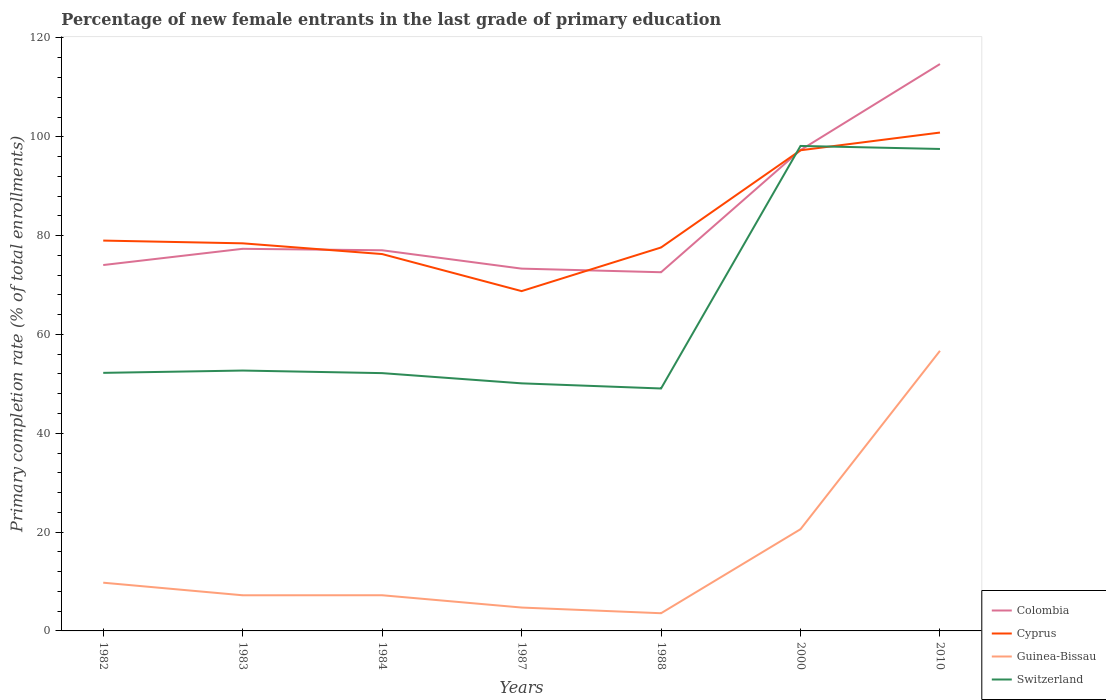Across all years, what is the maximum percentage of new female entrants in Guinea-Bissau?
Your response must be concise. 3.58. What is the total percentage of new female entrants in Cyprus in the graph?
Your response must be concise. -8.83. What is the difference between the highest and the second highest percentage of new female entrants in Cyprus?
Your answer should be compact. 32.09. What is the difference between the highest and the lowest percentage of new female entrants in Cyprus?
Provide a short and direct response. 2. Is the percentage of new female entrants in Colombia strictly greater than the percentage of new female entrants in Switzerland over the years?
Give a very brief answer. No. How many lines are there?
Give a very brief answer. 4. How many years are there in the graph?
Offer a terse response. 7. What is the difference between two consecutive major ticks on the Y-axis?
Your answer should be compact. 20. Does the graph contain any zero values?
Make the answer very short. No. What is the title of the graph?
Provide a succinct answer. Percentage of new female entrants in the last grade of primary education. What is the label or title of the X-axis?
Offer a terse response. Years. What is the label or title of the Y-axis?
Keep it short and to the point. Primary completion rate (% of total enrollments). What is the Primary completion rate (% of total enrollments) of Colombia in 1982?
Keep it short and to the point. 74.05. What is the Primary completion rate (% of total enrollments) of Cyprus in 1982?
Your answer should be compact. 79. What is the Primary completion rate (% of total enrollments) in Guinea-Bissau in 1982?
Give a very brief answer. 9.76. What is the Primary completion rate (% of total enrollments) in Switzerland in 1982?
Provide a succinct answer. 52.23. What is the Primary completion rate (% of total enrollments) of Colombia in 1983?
Give a very brief answer. 77.33. What is the Primary completion rate (% of total enrollments) in Cyprus in 1983?
Provide a short and direct response. 78.44. What is the Primary completion rate (% of total enrollments) in Guinea-Bissau in 1983?
Give a very brief answer. 7.21. What is the Primary completion rate (% of total enrollments) in Switzerland in 1983?
Provide a succinct answer. 52.7. What is the Primary completion rate (% of total enrollments) of Colombia in 1984?
Offer a terse response. 77.04. What is the Primary completion rate (% of total enrollments) of Cyprus in 1984?
Provide a short and direct response. 76.27. What is the Primary completion rate (% of total enrollments) of Guinea-Bissau in 1984?
Provide a short and direct response. 7.22. What is the Primary completion rate (% of total enrollments) in Switzerland in 1984?
Provide a short and direct response. 52.17. What is the Primary completion rate (% of total enrollments) in Colombia in 1987?
Your response must be concise. 73.32. What is the Primary completion rate (% of total enrollments) in Cyprus in 1987?
Your response must be concise. 68.77. What is the Primary completion rate (% of total enrollments) in Guinea-Bissau in 1987?
Provide a succinct answer. 4.73. What is the Primary completion rate (% of total enrollments) of Switzerland in 1987?
Your answer should be very brief. 50.11. What is the Primary completion rate (% of total enrollments) of Colombia in 1988?
Offer a terse response. 72.59. What is the Primary completion rate (% of total enrollments) in Cyprus in 1988?
Ensure brevity in your answer.  77.6. What is the Primary completion rate (% of total enrollments) of Guinea-Bissau in 1988?
Ensure brevity in your answer.  3.58. What is the Primary completion rate (% of total enrollments) in Switzerland in 1988?
Offer a very short reply. 49.06. What is the Primary completion rate (% of total enrollments) in Colombia in 2000?
Give a very brief answer. 97.31. What is the Primary completion rate (% of total enrollments) in Cyprus in 2000?
Provide a succinct answer. 97.27. What is the Primary completion rate (% of total enrollments) in Guinea-Bissau in 2000?
Give a very brief answer. 20.58. What is the Primary completion rate (% of total enrollments) in Switzerland in 2000?
Offer a very short reply. 98.15. What is the Primary completion rate (% of total enrollments) in Colombia in 2010?
Your response must be concise. 114.73. What is the Primary completion rate (% of total enrollments) in Cyprus in 2010?
Your answer should be very brief. 100.86. What is the Primary completion rate (% of total enrollments) in Guinea-Bissau in 2010?
Make the answer very short. 56.69. What is the Primary completion rate (% of total enrollments) in Switzerland in 2010?
Provide a short and direct response. 97.54. Across all years, what is the maximum Primary completion rate (% of total enrollments) of Colombia?
Your response must be concise. 114.73. Across all years, what is the maximum Primary completion rate (% of total enrollments) of Cyprus?
Keep it short and to the point. 100.86. Across all years, what is the maximum Primary completion rate (% of total enrollments) in Guinea-Bissau?
Make the answer very short. 56.69. Across all years, what is the maximum Primary completion rate (% of total enrollments) of Switzerland?
Provide a short and direct response. 98.15. Across all years, what is the minimum Primary completion rate (% of total enrollments) of Colombia?
Provide a succinct answer. 72.59. Across all years, what is the minimum Primary completion rate (% of total enrollments) in Cyprus?
Provide a succinct answer. 68.77. Across all years, what is the minimum Primary completion rate (% of total enrollments) in Guinea-Bissau?
Provide a succinct answer. 3.58. Across all years, what is the minimum Primary completion rate (% of total enrollments) in Switzerland?
Offer a very short reply. 49.06. What is the total Primary completion rate (% of total enrollments) in Colombia in the graph?
Give a very brief answer. 586.37. What is the total Primary completion rate (% of total enrollments) of Cyprus in the graph?
Provide a short and direct response. 578.21. What is the total Primary completion rate (% of total enrollments) in Guinea-Bissau in the graph?
Offer a very short reply. 109.78. What is the total Primary completion rate (% of total enrollments) in Switzerland in the graph?
Make the answer very short. 451.96. What is the difference between the Primary completion rate (% of total enrollments) in Colombia in 1982 and that in 1983?
Provide a succinct answer. -3.28. What is the difference between the Primary completion rate (% of total enrollments) of Cyprus in 1982 and that in 1983?
Keep it short and to the point. 0.56. What is the difference between the Primary completion rate (% of total enrollments) of Guinea-Bissau in 1982 and that in 1983?
Offer a very short reply. 2.55. What is the difference between the Primary completion rate (% of total enrollments) in Switzerland in 1982 and that in 1983?
Give a very brief answer. -0.47. What is the difference between the Primary completion rate (% of total enrollments) in Colombia in 1982 and that in 1984?
Provide a succinct answer. -2.99. What is the difference between the Primary completion rate (% of total enrollments) in Cyprus in 1982 and that in 1984?
Your response must be concise. 2.73. What is the difference between the Primary completion rate (% of total enrollments) in Guinea-Bissau in 1982 and that in 1984?
Offer a very short reply. 2.54. What is the difference between the Primary completion rate (% of total enrollments) of Switzerland in 1982 and that in 1984?
Provide a short and direct response. 0.06. What is the difference between the Primary completion rate (% of total enrollments) of Colombia in 1982 and that in 1987?
Keep it short and to the point. 0.73. What is the difference between the Primary completion rate (% of total enrollments) of Cyprus in 1982 and that in 1987?
Your response must be concise. 10.23. What is the difference between the Primary completion rate (% of total enrollments) of Guinea-Bissau in 1982 and that in 1987?
Provide a succinct answer. 5.03. What is the difference between the Primary completion rate (% of total enrollments) in Switzerland in 1982 and that in 1987?
Your answer should be compact. 2.12. What is the difference between the Primary completion rate (% of total enrollments) of Colombia in 1982 and that in 1988?
Provide a succinct answer. 1.46. What is the difference between the Primary completion rate (% of total enrollments) in Cyprus in 1982 and that in 1988?
Offer a very short reply. 1.4. What is the difference between the Primary completion rate (% of total enrollments) of Guinea-Bissau in 1982 and that in 1988?
Give a very brief answer. 6.18. What is the difference between the Primary completion rate (% of total enrollments) of Switzerland in 1982 and that in 1988?
Your answer should be very brief. 3.16. What is the difference between the Primary completion rate (% of total enrollments) in Colombia in 1982 and that in 2000?
Keep it short and to the point. -23.26. What is the difference between the Primary completion rate (% of total enrollments) in Cyprus in 1982 and that in 2000?
Your response must be concise. -18.28. What is the difference between the Primary completion rate (% of total enrollments) in Guinea-Bissau in 1982 and that in 2000?
Keep it short and to the point. -10.82. What is the difference between the Primary completion rate (% of total enrollments) in Switzerland in 1982 and that in 2000?
Offer a very short reply. -45.92. What is the difference between the Primary completion rate (% of total enrollments) in Colombia in 1982 and that in 2010?
Your response must be concise. -40.68. What is the difference between the Primary completion rate (% of total enrollments) in Cyprus in 1982 and that in 2010?
Your response must be concise. -21.86. What is the difference between the Primary completion rate (% of total enrollments) in Guinea-Bissau in 1982 and that in 2010?
Provide a short and direct response. -46.93. What is the difference between the Primary completion rate (% of total enrollments) of Switzerland in 1982 and that in 2010?
Ensure brevity in your answer.  -45.31. What is the difference between the Primary completion rate (% of total enrollments) of Colombia in 1983 and that in 1984?
Provide a short and direct response. 0.3. What is the difference between the Primary completion rate (% of total enrollments) in Cyprus in 1983 and that in 1984?
Ensure brevity in your answer.  2.17. What is the difference between the Primary completion rate (% of total enrollments) in Guinea-Bissau in 1983 and that in 1984?
Offer a very short reply. -0.01. What is the difference between the Primary completion rate (% of total enrollments) in Switzerland in 1983 and that in 1984?
Make the answer very short. 0.52. What is the difference between the Primary completion rate (% of total enrollments) in Colombia in 1983 and that in 1987?
Offer a very short reply. 4.01. What is the difference between the Primary completion rate (% of total enrollments) in Cyprus in 1983 and that in 1987?
Provide a short and direct response. 9.67. What is the difference between the Primary completion rate (% of total enrollments) in Guinea-Bissau in 1983 and that in 1987?
Make the answer very short. 2.48. What is the difference between the Primary completion rate (% of total enrollments) of Switzerland in 1983 and that in 1987?
Keep it short and to the point. 2.59. What is the difference between the Primary completion rate (% of total enrollments) of Colombia in 1983 and that in 1988?
Your answer should be very brief. 4.74. What is the difference between the Primary completion rate (% of total enrollments) of Cyprus in 1983 and that in 1988?
Offer a terse response. 0.84. What is the difference between the Primary completion rate (% of total enrollments) of Guinea-Bissau in 1983 and that in 1988?
Ensure brevity in your answer.  3.63. What is the difference between the Primary completion rate (% of total enrollments) of Switzerland in 1983 and that in 1988?
Make the answer very short. 3.63. What is the difference between the Primary completion rate (% of total enrollments) in Colombia in 1983 and that in 2000?
Offer a terse response. -19.98. What is the difference between the Primary completion rate (% of total enrollments) in Cyprus in 1983 and that in 2000?
Provide a short and direct response. -18.83. What is the difference between the Primary completion rate (% of total enrollments) of Guinea-Bissau in 1983 and that in 2000?
Provide a short and direct response. -13.37. What is the difference between the Primary completion rate (% of total enrollments) in Switzerland in 1983 and that in 2000?
Make the answer very short. -45.46. What is the difference between the Primary completion rate (% of total enrollments) in Colombia in 1983 and that in 2010?
Provide a short and direct response. -37.39. What is the difference between the Primary completion rate (% of total enrollments) of Cyprus in 1983 and that in 2010?
Offer a terse response. -22.42. What is the difference between the Primary completion rate (% of total enrollments) in Guinea-Bissau in 1983 and that in 2010?
Ensure brevity in your answer.  -49.48. What is the difference between the Primary completion rate (% of total enrollments) of Switzerland in 1983 and that in 2010?
Provide a succinct answer. -44.84. What is the difference between the Primary completion rate (% of total enrollments) of Colombia in 1984 and that in 1987?
Provide a short and direct response. 3.72. What is the difference between the Primary completion rate (% of total enrollments) in Cyprus in 1984 and that in 1987?
Provide a short and direct response. 7.5. What is the difference between the Primary completion rate (% of total enrollments) in Guinea-Bissau in 1984 and that in 1987?
Offer a terse response. 2.49. What is the difference between the Primary completion rate (% of total enrollments) in Switzerland in 1984 and that in 1987?
Ensure brevity in your answer.  2.07. What is the difference between the Primary completion rate (% of total enrollments) in Colombia in 1984 and that in 1988?
Keep it short and to the point. 4.45. What is the difference between the Primary completion rate (% of total enrollments) of Cyprus in 1984 and that in 1988?
Offer a very short reply. -1.33. What is the difference between the Primary completion rate (% of total enrollments) of Guinea-Bissau in 1984 and that in 1988?
Your answer should be very brief. 3.64. What is the difference between the Primary completion rate (% of total enrollments) in Switzerland in 1984 and that in 1988?
Keep it short and to the point. 3.11. What is the difference between the Primary completion rate (% of total enrollments) of Colombia in 1984 and that in 2000?
Your answer should be very brief. -20.27. What is the difference between the Primary completion rate (% of total enrollments) in Cyprus in 1984 and that in 2000?
Provide a short and direct response. -21. What is the difference between the Primary completion rate (% of total enrollments) in Guinea-Bissau in 1984 and that in 2000?
Your answer should be compact. -13.37. What is the difference between the Primary completion rate (% of total enrollments) in Switzerland in 1984 and that in 2000?
Offer a very short reply. -45.98. What is the difference between the Primary completion rate (% of total enrollments) in Colombia in 1984 and that in 2010?
Give a very brief answer. -37.69. What is the difference between the Primary completion rate (% of total enrollments) of Cyprus in 1984 and that in 2010?
Your answer should be compact. -24.59. What is the difference between the Primary completion rate (% of total enrollments) of Guinea-Bissau in 1984 and that in 2010?
Your response must be concise. -49.47. What is the difference between the Primary completion rate (% of total enrollments) in Switzerland in 1984 and that in 2010?
Keep it short and to the point. -45.37. What is the difference between the Primary completion rate (% of total enrollments) in Colombia in 1987 and that in 1988?
Keep it short and to the point. 0.73. What is the difference between the Primary completion rate (% of total enrollments) in Cyprus in 1987 and that in 1988?
Provide a short and direct response. -8.83. What is the difference between the Primary completion rate (% of total enrollments) of Guinea-Bissau in 1987 and that in 1988?
Make the answer very short. 1.15. What is the difference between the Primary completion rate (% of total enrollments) in Switzerland in 1987 and that in 1988?
Keep it short and to the point. 1.04. What is the difference between the Primary completion rate (% of total enrollments) of Colombia in 1987 and that in 2000?
Provide a succinct answer. -23.99. What is the difference between the Primary completion rate (% of total enrollments) of Cyprus in 1987 and that in 2000?
Ensure brevity in your answer.  -28.5. What is the difference between the Primary completion rate (% of total enrollments) in Guinea-Bissau in 1987 and that in 2000?
Your answer should be compact. -15.85. What is the difference between the Primary completion rate (% of total enrollments) in Switzerland in 1987 and that in 2000?
Offer a terse response. -48.05. What is the difference between the Primary completion rate (% of total enrollments) of Colombia in 1987 and that in 2010?
Ensure brevity in your answer.  -41.41. What is the difference between the Primary completion rate (% of total enrollments) in Cyprus in 1987 and that in 2010?
Make the answer very short. -32.09. What is the difference between the Primary completion rate (% of total enrollments) of Guinea-Bissau in 1987 and that in 2010?
Give a very brief answer. -51.96. What is the difference between the Primary completion rate (% of total enrollments) of Switzerland in 1987 and that in 2010?
Ensure brevity in your answer.  -47.43. What is the difference between the Primary completion rate (% of total enrollments) of Colombia in 1988 and that in 2000?
Provide a short and direct response. -24.72. What is the difference between the Primary completion rate (% of total enrollments) of Cyprus in 1988 and that in 2000?
Provide a short and direct response. -19.67. What is the difference between the Primary completion rate (% of total enrollments) of Guinea-Bissau in 1988 and that in 2000?
Your answer should be compact. -17. What is the difference between the Primary completion rate (% of total enrollments) in Switzerland in 1988 and that in 2000?
Keep it short and to the point. -49.09. What is the difference between the Primary completion rate (% of total enrollments) of Colombia in 1988 and that in 2010?
Your answer should be very brief. -42.14. What is the difference between the Primary completion rate (% of total enrollments) of Cyprus in 1988 and that in 2010?
Your response must be concise. -23.26. What is the difference between the Primary completion rate (% of total enrollments) of Guinea-Bissau in 1988 and that in 2010?
Provide a succinct answer. -53.11. What is the difference between the Primary completion rate (% of total enrollments) of Switzerland in 1988 and that in 2010?
Offer a very short reply. -48.47. What is the difference between the Primary completion rate (% of total enrollments) in Colombia in 2000 and that in 2010?
Your response must be concise. -17.41. What is the difference between the Primary completion rate (% of total enrollments) in Cyprus in 2000 and that in 2010?
Ensure brevity in your answer.  -3.59. What is the difference between the Primary completion rate (% of total enrollments) of Guinea-Bissau in 2000 and that in 2010?
Provide a short and direct response. -36.1. What is the difference between the Primary completion rate (% of total enrollments) of Switzerland in 2000 and that in 2010?
Your answer should be compact. 0.61. What is the difference between the Primary completion rate (% of total enrollments) of Colombia in 1982 and the Primary completion rate (% of total enrollments) of Cyprus in 1983?
Make the answer very short. -4.39. What is the difference between the Primary completion rate (% of total enrollments) of Colombia in 1982 and the Primary completion rate (% of total enrollments) of Guinea-Bissau in 1983?
Make the answer very short. 66.84. What is the difference between the Primary completion rate (% of total enrollments) in Colombia in 1982 and the Primary completion rate (% of total enrollments) in Switzerland in 1983?
Give a very brief answer. 21.35. What is the difference between the Primary completion rate (% of total enrollments) in Cyprus in 1982 and the Primary completion rate (% of total enrollments) in Guinea-Bissau in 1983?
Provide a succinct answer. 71.78. What is the difference between the Primary completion rate (% of total enrollments) in Cyprus in 1982 and the Primary completion rate (% of total enrollments) in Switzerland in 1983?
Make the answer very short. 26.3. What is the difference between the Primary completion rate (% of total enrollments) in Guinea-Bissau in 1982 and the Primary completion rate (% of total enrollments) in Switzerland in 1983?
Your response must be concise. -42.94. What is the difference between the Primary completion rate (% of total enrollments) of Colombia in 1982 and the Primary completion rate (% of total enrollments) of Cyprus in 1984?
Ensure brevity in your answer.  -2.22. What is the difference between the Primary completion rate (% of total enrollments) of Colombia in 1982 and the Primary completion rate (% of total enrollments) of Guinea-Bissau in 1984?
Keep it short and to the point. 66.83. What is the difference between the Primary completion rate (% of total enrollments) in Colombia in 1982 and the Primary completion rate (% of total enrollments) in Switzerland in 1984?
Keep it short and to the point. 21.88. What is the difference between the Primary completion rate (% of total enrollments) of Cyprus in 1982 and the Primary completion rate (% of total enrollments) of Guinea-Bissau in 1984?
Offer a terse response. 71.78. What is the difference between the Primary completion rate (% of total enrollments) in Cyprus in 1982 and the Primary completion rate (% of total enrollments) in Switzerland in 1984?
Make the answer very short. 26.82. What is the difference between the Primary completion rate (% of total enrollments) in Guinea-Bissau in 1982 and the Primary completion rate (% of total enrollments) in Switzerland in 1984?
Ensure brevity in your answer.  -42.41. What is the difference between the Primary completion rate (% of total enrollments) in Colombia in 1982 and the Primary completion rate (% of total enrollments) in Cyprus in 1987?
Offer a terse response. 5.28. What is the difference between the Primary completion rate (% of total enrollments) of Colombia in 1982 and the Primary completion rate (% of total enrollments) of Guinea-Bissau in 1987?
Provide a succinct answer. 69.32. What is the difference between the Primary completion rate (% of total enrollments) of Colombia in 1982 and the Primary completion rate (% of total enrollments) of Switzerland in 1987?
Your answer should be compact. 23.94. What is the difference between the Primary completion rate (% of total enrollments) in Cyprus in 1982 and the Primary completion rate (% of total enrollments) in Guinea-Bissau in 1987?
Your answer should be compact. 74.27. What is the difference between the Primary completion rate (% of total enrollments) of Cyprus in 1982 and the Primary completion rate (% of total enrollments) of Switzerland in 1987?
Your answer should be compact. 28.89. What is the difference between the Primary completion rate (% of total enrollments) in Guinea-Bissau in 1982 and the Primary completion rate (% of total enrollments) in Switzerland in 1987?
Ensure brevity in your answer.  -40.35. What is the difference between the Primary completion rate (% of total enrollments) of Colombia in 1982 and the Primary completion rate (% of total enrollments) of Cyprus in 1988?
Ensure brevity in your answer.  -3.55. What is the difference between the Primary completion rate (% of total enrollments) in Colombia in 1982 and the Primary completion rate (% of total enrollments) in Guinea-Bissau in 1988?
Ensure brevity in your answer.  70.47. What is the difference between the Primary completion rate (% of total enrollments) in Colombia in 1982 and the Primary completion rate (% of total enrollments) in Switzerland in 1988?
Make the answer very short. 24.98. What is the difference between the Primary completion rate (% of total enrollments) in Cyprus in 1982 and the Primary completion rate (% of total enrollments) in Guinea-Bissau in 1988?
Give a very brief answer. 75.42. What is the difference between the Primary completion rate (% of total enrollments) of Cyprus in 1982 and the Primary completion rate (% of total enrollments) of Switzerland in 1988?
Keep it short and to the point. 29.93. What is the difference between the Primary completion rate (% of total enrollments) in Guinea-Bissau in 1982 and the Primary completion rate (% of total enrollments) in Switzerland in 1988?
Provide a succinct answer. -39.3. What is the difference between the Primary completion rate (% of total enrollments) of Colombia in 1982 and the Primary completion rate (% of total enrollments) of Cyprus in 2000?
Provide a short and direct response. -23.22. What is the difference between the Primary completion rate (% of total enrollments) in Colombia in 1982 and the Primary completion rate (% of total enrollments) in Guinea-Bissau in 2000?
Give a very brief answer. 53.46. What is the difference between the Primary completion rate (% of total enrollments) in Colombia in 1982 and the Primary completion rate (% of total enrollments) in Switzerland in 2000?
Offer a terse response. -24.1. What is the difference between the Primary completion rate (% of total enrollments) in Cyprus in 1982 and the Primary completion rate (% of total enrollments) in Guinea-Bissau in 2000?
Your answer should be compact. 58.41. What is the difference between the Primary completion rate (% of total enrollments) of Cyprus in 1982 and the Primary completion rate (% of total enrollments) of Switzerland in 2000?
Ensure brevity in your answer.  -19.15. What is the difference between the Primary completion rate (% of total enrollments) in Guinea-Bissau in 1982 and the Primary completion rate (% of total enrollments) in Switzerland in 2000?
Provide a short and direct response. -88.39. What is the difference between the Primary completion rate (% of total enrollments) in Colombia in 1982 and the Primary completion rate (% of total enrollments) in Cyprus in 2010?
Provide a short and direct response. -26.81. What is the difference between the Primary completion rate (% of total enrollments) of Colombia in 1982 and the Primary completion rate (% of total enrollments) of Guinea-Bissau in 2010?
Offer a terse response. 17.36. What is the difference between the Primary completion rate (% of total enrollments) in Colombia in 1982 and the Primary completion rate (% of total enrollments) in Switzerland in 2010?
Provide a succinct answer. -23.49. What is the difference between the Primary completion rate (% of total enrollments) of Cyprus in 1982 and the Primary completion rate (% of total enrollments) of Guinea-Bissau in 2010?
Offer a very short reply. 22.31. What is the difference between the Primary completion rate (% of total enrollments) in Cyprus in 1982 and the Primary completion rate (% of total enrollments) in Switzerland in 2010?
Offer a very short reply. -18.54. What is the difference between the Primary completion rate (% of total enrollments) of Guinea-Bissau in 1982 and the Primary completion rate (% of total enrollments) of Switzerland in 2010?
Provide a succinct answer. -87.78. What is the difference between the Primary completion rate (% of total enrollments) of Colombia in 1983 and the Primary completion rate (% of total enrollments) of Cyprus in 1984?
Offer a terse response. 1.06. What is the difference between the Primary completion rate (% of total enrollments) of Colombia in 1983 and the Primary completion rate (% of total enrollments) of Guinea-Bissau in 1984?
Keep it short and to the point. 70.11. What is the difference between the Primary completion rate (% of total enrollments) in Colombia in 1983 and the Primary completion rate (% of total enrollments) in Switzerland in 1984?
Make the answer very short. 25.16. What is the difference between the Primary completion rate (% of total enrollments) in Cyprus in 1983 and the Primary completion rate (% of total enrollments) in Guinea-Bissau in 1984?
Ensure brevity in your answer.  71.22. What is the difference between the Primary completion rate (% of total enrollments) of Cyprus in 1983 and the Primary completion rate (% of total enrollments) of Switzerland in 1984?
Make the answer very short. 26.27. What is the difference between the Primary completion rate (% of total enrollments) of Guinea-Bissau in 1983 and the Primary completion rate (% of total enrollments) of Switzerland in 1984?
Your answer should be compact. -44.96. What is the difference between the Primary completion rate (% of total enrollments) in Colombia in 1983 and the Primary completion rate (% of total enrollments) in Cyprus in 1987?
Provide a short and direct response. 8.56. What is the difference between the Primary completion rate (% of total enrollments) of Colombia in 1983 and the Primary completion rate (% of total enrollments) of Guinea-Bissau in 1987?
Your answer should be compact. 72.6. What is the difference between the Primary completion rate (% of total enrollments) of Colombia in 1983 and the Primary completion rate (% of total enrollments) of Switzerland in 1987?
Provide a short and direct response. 27.23. What is the difference between the Primary completion rate (% of total enrollments) of Cyprus in 1983 and the Primary completion rate (% of total enrollments) of Guinea-Bissau in 1987?
Your response must be concise. 73.71. What is the difference between the Primary completion rate (% of total enrollments) of Cyprus in 1983 and the Primary completion rate (% of total enrollments) of Switzerland in 1987?
Offer a very short reply. 28.34. What is the difference between the Primary completion rate (% of total enrollments) in Guinea-Bissau in 1983 and the Primary completion rate (% of total enrollments) in Switzerland in 1987?
Offer a very short reply. -42.89. What is the difference between the Primary completion rate (% of total enrollments) in Colombia in 1983 and the Primary completion rate (% of total enrollments) in Cyprus in 1988?
Provide a succinct answer. -0.27. What is the difference between the Primary completion rate (% of total enrollments) in Colombia in 1983 and the Primary completion rate (% of total enrollments) in Guinea-Bissau in 1988?
Provide a succinct answer. 73.75. What is the difference between the Primary completion rate (% of total enrollments) in Colombia in 1983 and the Primary completion rate (% of total enrollments) in Switzerland in 1988?
Your answer should be compact. 28.27. What is the difference between the Primary completion rate (% of total enrollments) of Cyprus in 1983 and the Primary completion rate (% of total enrollments) of Guinea-Bissau in 1988?
Your answer should be very brief. 74.86. What is the difference between the Primary completion rate (% of total enrollments) in Cyprus in 1983 and the Primary completion rate (% of total enrollments) in Switzerland in 1988?
Ensure brevity in your answer.  29.38. What is the difference between the Primary completion rate (% of total enrollments) of Guinea-Bissau in 1983 and the Primary completion rate (% of total enrollments) of Switzerland in 1988?
Provide a short and direct response. -41.85. What is the difference between the Primary completion rate (% of total enrollments) in Colombia in 1983 and the Primary completion rate (% of total enrollments) in Cyprus in 2000?
Ensure brevity in your answer.  -19.94. What is the difference between the Primary completion rate (% of total enrollments) in Colombia in 1983 and the Primary completion rate (% of total enrollments) in Guinea-Bissau in 2000?
Your response must be concise. 56.75. What is the difference between the Primary completion rate (% of total enrollments) in Colombia in 1983 and the Primary completion rate (% of total enrollments) in Switzerland in 2000?
Give a very brief answer. -20.82. What is the difference between the Primary completion rate (% of total enrollments) in Cyprus in 1983 and the Primary completion rate (% of total enrollments) in Guinea-Bissau in 2000?
Make the answer very short. 57.86. What is the difference between the Primary completion rate (% of total enrollments) in Cyprus in 1983 and the Primary completion rate (% of total enrollments) in Switzerland in 2000?
Make the answer very short. -19.71. What is the difference between the Primary completion rate (% of total enrollments) of Guinea-Bissau in 1983 and the Primary completion rate (% of total enrollments) of Switzerland in 2000?
Provide a succinct answer. -90.94. What is the difference between the Primary completion rate (% of total enrollments) in Colombia in 1983 and the Primary completion rate (% of total enrollments) in Cyprus in 2010?
Give a very brief answer. -23.53. What is the difference between the Primary completion rate (% of total enrollments) in Colombia in 1983 and the Primary completion rate (% of total enrollments) in Guinea-Bissau in 2010?
Your answer should be very brief. 20.65. What is the difference between the Primary completion rate (% of total enrollments) in Colombia in 1983 and the Primary completion rate (% of total enrollments) in Switzerland in 2010?
Your answer should be compact. -20.21. What is the difference between the Primary completion rate (% of total enrollments) in Cyprus in 1983 and the Primary completion rate (% of total enrollments) in Guinea-Bissau in 2010?
Make the answer very short. 21.75. What is the difference between the Primary completion rate (% of total enrollments) of Cyprus in 1983 and the Primary completion rate (% of total enrollments) of Switzerland in 2010?
Provide a succinct answer. -19.1. What is the difference between the Primary completion rate (% of total enrollments) of Guinea-Bissau in 1983 and the Primary completion rate (% of total enrollments) of Switzerland in 2010?
Provide a short and direct response. -90.33. What is the difference between the Primary completion rate (% of total enrollments) of Colombia in 1984 and the Primary completion rate (% of total enrollments) of Cyprus in 1987?
Offer a very short reply. 8.27. What is the difference between the Primary completion rate (% of total enrollments) of Colombia in 1984 and the Primary completion rate (% of total enrollments) of Guinea-Bissau in 1987?
Your answer should be compact. 72.31. What is the difference between the Primary completion rate (% of total enrollments) in Colombia in 1984 and the Primary completion rate (% of total enrollments) in Switzerland in 1987?
Offer a terse response. 26.93. What is the difference between the Primary completion rate (% of total enrollments) in Cyprus in 1984 and the Primary completion rate (% of total enrollments) in Guinea-Bissau in 1987?
Provide a succinct answer. 71.54. What is the difference between the Primary completion rate (% of total enrollments) of Cyprus in 1984 and the Primary completion rate (% of total enrollments) of Switzerland in 1987?
Give a very brief answer. 26.16. What is the difference between the Primary completion rate (% of total enrollments) in Guinea-Bissau in 1984 and the Primary completion rate (% of total enrollments) in Switzerland in 1987?
Provide a succinct answer. -42.89. What is the difference between the Primary completion rate (% of total enrollments) of Colombia in 1984 and the Primary completion rate (% of total enrollments) of Cyprus in 1988?
Keep it short and to the point. -0.56. What is the difference between the Primary completion rate (% of total enrollments) of Colombia in 1984 and the Primary completion rate (% of total enrollments) of Guinea-Bissau in 1988?
Provide a succinct answer. 73.46. What is the difference between the Primary completion rate (% of total enrollments) of Colombia in 1984 and the Primary completion rate (% of total enrollments) of Switzerland in 1988?
Your answer should be compact. 27.97. What is the difference between the Primary completion rate (% of total enrollments) in Cyprus in 1984 and the Primary completion rate (% of total enrollments) in Guinea-Bissau in 1988?
Your answer should be very brief. 72.69. What is the difference between the Primary completion rate (% of total enrollments) in Cyprus in 1984 and the Primary completion rate (% of total enrollments) in Switzerland in 1988?
Give a very brief answer. 27.21. What is the difference between the Primary completion rate (% of total enrollments) of Guinea-Bissau in 1984 and the Primary completion rate (% of total enrollments) of Switzerland in 1988?
Keep it short and to the point. -41.85. What is the difference between the Primary completion rate (% of total enrollments) in Colombia in 1984 and the Primary completion rate (% of total enrollments) in Cyprus in 2000?
Offer a terse response. -20.24. What is the difference between the Primary completion rate (% of total enrollments) in Colombia in 1984 and the Primary completion rate (% of total enrollments) in Guinea-Bissau in 2000?
Your response must be concise. 56.45. What is the difference between the Primary completion rate (% of total enrollments) of Colombia in 1984 and the Primary completion rate (% of total enrollments) of Switzerland in 2000?
Your response must be concise. -21.11. What is the difference between the Primary completion rate (% of total enrollments) in Cyprus in 1984 and the Primary completion rate (% of total enrollments) in Guinea-Bissau in 2000?
Your answer should be compact. 55.69. What is the difference between the Primary completion rate (% of total enrollments) in Cyprus in 1984 and the Primary completion rate (% of total enrollments) in Switzerland in 2000?
Keep it short and to the point. -21.88. What is the difference between the Primary completion rate (% of total enrollments) of Guinea-Bissau in 1984 and the Primary completion rate (% of total enrollments) of Switzerland in 2000?
Ensure brevity in your answer.  -90.93. What is the difference between the Primary completion rate (% of total enrollments) in Colombia in 1984 and the Primary completion rate (% of total enrollments) in Cyprus in 2010?
Provide a succinct answer. -23.82. What is the difference between the Primary completion rate (% of total enrollments) of Colombia in 1984 and the Primary completion rate (% of total enrollments) of Guinea-Bissau in 2010?
Your answer should be compact. 20.35. What is the difference between the Primary completion rate (% of total enrollments) of Colombia in 1984 and the Primary completion rate (% of total enrollments) of Switzerland in 2010?
Give a very brief answer. -20.5. What is the difference between the Primary completion rate (% of total enrollments) in Cyprus in 1984 and the Primary completion rate (% of total enrollments) in Guinea-Bissau in 2010?
Offer a very short reply. 19.58. What is the difference between the Primary completion rate (% of total enrollments) in Cyprus in 1984 and the Primary completion rate (% of total enrollments) in Switzerland in 2010?
Offer a very short reply. -21.27. What is the difference between the Primary completion rate (% of total enrollments) in Guinea-Bissau in 1984 and the Primary completion rate (% of total enrollments) in Switzerland in 2010?
Ensure brevity in your answer.  -90.32. What is the difference between the Primary completion rate (% of total enrollments) in Colombia in 1987 and the Primary completion rate (% of total enrollments) in Cyprus in 1988?
Offer a terse response. -4.28. What is the difference between the Primary completion rate (% of total enrollments) in Colombia in 1987 and the Primary completion rate (% of total enrollments) in Guinea-Bissau in 1988?
Keep it short and to the point. 69.74. What is the difference between the Primary completion rate (% of total enrollments) of Colombia in 1987 and the Primary completion rate (% of total enrollments) of Switzerland in 1988?
Provide a succinct answer. 24.26. What is the difference between the Primary completion rate (% of total enrollments) in Cyprus in 1987 and the Primary completion rate (% of total enrollments) in Guinea-Bissau in 1988?
Provide a succinct answer. 65.19. What is the difference between the Primary completion rate (% of total enrollments) in Cyprus in 1987 and the Primary completion rate (% of total enrollments) in Switzerland in 1988?
Your answer should be very brief. 19.71. What is the difference between the Primary completion rate (% of total enrollments) of Guinea-Bissau in 1987 and the Primary completion rate (% of total enrollments) of Switzerland in 1988?
Offer a terse response. -44.33. What is the difference between the Primary completion rate (% of total enrollments) of Colombia in 1987 and the Primary completion rate (% of total enrollments) of Cyprus in 2000?
Your response must be concise. -23.95. What is the difference between the Primary completion rate (% of total enrollments) in Colombia in 1987 and the Primary completion rate (% of total enrollments) in Guinea-Bissau in 2000?
Offer a very short reply. 52.74. What is the difference between the Primary completion rate (% of total enrollments) in Colombia in 1987 and the Primary completion rate (% of total enrollments) in Switzerland in 2000?
Ensure brevity in your answer.  -24.83. What is the difference between the Primary completion rate (% of total enrollments) of Cyprus in 1987 and the Primary completion rate (% of total enrollments) of Guinea-Bissau in 2000?
Offer a terse response. 48.19. What is the difference between the Primary completion rate (% of total enrollments) of Cyprus in 1987 and the Primary completion rate (% of total enrollments) of Switzerland in 2000?
Offer a terse response. -29.38. What is the difference between the Primary completion rate (% of total enrollments) in Guinea-Bissau in 1987 and the Primary completion rate (% of total enrollments) in Switzerland in 2000?
Give a very brief answer. -93.42. What is the difference between the Primary completion rate (% of total enrollments) in Colombia in 1987 and the Primary completion rate (% of total enrollments) in Cyprus in 2010?
Give a very brief answer. -27.54. What is the difference between the Primary completion rate (% of total enrollments) of Colombia in 1987 and the Primary completion rate (% of total enrollments) of Guinea-Bissau in 2010?
Provide a succinct answer. 16.63. What is the difference between the Primary completion rate (% of total enrollments) in Colombia in 1987 and the Primary completion rate (% of total enrollments) in Switzerland in 2010?
Ensure brevity in your answer.  -24.22. What is the difference between the Primary completion rate (% of total enrollments) of Cyprus in 1987 and the Primary completion rate (% of total enrollments) of Guinea-Bissau in 2010?
Give a very brief answer. 12.08. What is the difference between the Primary completion rate (% of total enrollments) of Cyprus in 1987 and the Primary completion rate (% of total enrollments) of Switzerland in 2010?
Give a very brief answer. -28.77. What is the difference between the Primary completion rate (% of total enrollments) of Guinea-Bissau in 1987 and the Primary completion rate (% of total enrollments) of Switzerland in 2010?
Your answer should be very brief. -92.81. What is the difference between the Primary completion rate (% of total enrollments) of Colombia in 1988 and the Primary completion rate (% of total enrollments) of Cyprus in 2000?
Your answer should be very brief. -24.68. What is the difference between the Primary completion rate (% of total enrollments) of Colombia in 1988 and the Primary completion rate (% of total enrollments) of Guinea-Bissau in 2000?
Ensure brevity in your answer.  52.01. What is the difference between the Primary completion rate (% of total enrollments) in Colombia in 1988 and the Primary completion rate (% of total enrollments) in Switzerland in 2000?
Offer a terse response. -25.56. What is the difference between the Primary completion rate (% of total enrollments) in Cyprus in 1988 and the Primary completion rate (% of total enrollments) in Guinea-Bissau in 2000?
Offer a very short reply. 57.02. What is the difference between the Primary completion rate (% of total enrollments) of Cyprus in 1988 and the Primary completion rate (% of total enrollments) of Switzerland in 2000?
Provide a short and direct response. -20.55. What is the difference between the Primary completion rate (% of total enrollments) in Guinea-Bissau in 1988 and the Primary completion rate (% of total enrollments) in Switzerland in 2000?
Provide a short and direct response. -94.57. What is the difference between the Primary completion rate (% of total enrollments) in Colombia in 1988 and the Primary completion rate (% of total enrollments) in Cyprus in 2010?
Provide a succinct answer. -28.27. What is the difference between the Primary completion rate (% of total enrollments) of Colombia in 1988 and the Primary completion rate (% of total enrollments) of Guinea-Bissau in 2010?
Give a very brief answer. 15.9. What is the difference between the Primary completion rate (% of total enrollments) of Colombia in 1988 and the Primary completion rate (% of total enrollments) of Switzerland in 2010?
Give a very brief answer. -24.95. What is the difference between the Primary completion rate (% of total enrollments) of Cyprus in 1988 and the Primary completion rate (% of total enrollments) of Guinea-Bissau in 2010?
Provide a short and direct response. 20.91. What is the difference between the Primary completion rate (% of total enrollments) of Cyprus in 1988 and the Primary completion rate (% of total enrollments) of Switzerland in 2010?
Keep it short and to the point. -19.94. What is the difference between the Primary completion rate (% of total enrollments) of Guinea-Bissau in 1988 and the Primary completion rate (% of total enrollments) of Switzerland in 2010?
Give a very brief answer. -93.96. What is the difference between the Primary completion rate (% of total enrollments) in Colombia in 2000 and the Primary completion rate (% of total enrollments) in Cyprus in 2010?
Your answer should be very brief. -3.55. What is the difference between the Primary completion rate (% of total enrollments) of Colombia in 2000 and the Primary completion rate (% of total enrollments) of Guinea-Bissau in 2010?
Give a very brief answer. 40.62. What is the difference between the Primary completion rate (% of total enrollments) of Colombia in 2000 and the Primary completion rate (% of total enrollments) of Switzerland in 2010?
Provide a succinct answer. -0.23. What is the difference between the Primary completion rate (% of total enrollments) of Cyprus in 2000 and the Primary completion rate (% of total enrollments) of Guinea-Bissau in 2010?
Your answer should be compact. 40.59. What is the difference between the Primary completion rate (% of total enrollments) of Cyprus in 2000 and the Primary completion rate (% of total enrollments) of Switzerland in 2010?
Provide a succinct answer. -0.27. What is the difference between the Primary completion rate (% of total enrollments) in Guinea-Bissau in 2000 and the Primary completion rate (% of total enrollments) in Switzerland in 2010?
Your answer should be very brief. -76.96. What is the average Primary completion rate (% of total enrollments) in Colombia per year?
Your answer should be compact. 83.77. What is the average Primary completion rate (% of total enrollments) in Cyprus per year?
Provide a succinct answer. 82.6. What is the average Primary completion rate (% of total enrollments) in Guinea-Bissau per year?
Ensure brevity in your answer.  15.68. What is the average Primary completion rate (% of total enrollments) in Switzerland per year?
Provide a succinct answer. 64.57. In the year 1982, what is the difference between the Primary completion rate (% of total enrollments) of Colombia and Primary completion rate (% of total enrollments) of Cyprus?
Offer a terse response. -4.95. In the year 1982, what is the difference between the Primary completion rate (% of total enrollments) of Colombia and Primary completion rate (% of total enrollments) of Guinea-Bissau?
Offer a terse response. 64.29. In the year 1982, what is the difference between the Primary completion rate (% of total enrollments) of Colombia and Primary completion rate (% of total enrollments) of Switzerland?
Ensure brevity in your answer.  21.82. In the year 1982, what is the difference between the Primary completion rate (% of total enrollments) of Cyprus and Primary completion rate (% of total enrollments) of Guinea-Bissau?
Keep it short and to the point. 69.24. In the year 1982, what is the difference between the Primary completion rate (% of total enrollments) of Cyprus and Primary completion rate (% of total enrollments) of Switzerland?
Your answer should be very brief. 26.77. In the year 1982, what is the difference between the Primary completion rate (% of total enrollments) in Guinea-Bissau and Primary completion rate (% of total enrollments) in Switzerland?
Provide a succinct answer. -42.47. In the year 1983, what is the difference between the Primary completion rate (% of total enrollments) of Colombia and Primary completion rate (% of total enrollments) of Cyprus?
Provide a succinct answer. -1.11. In the year 1983, what is the difference between the Primary completion rate (% of total enrollments) of Colombia and Primary completion rate (% of total enrollments) of Guinea-Bissau?
Your response must be concise. 70.12. In the year 1983, what is the difference between the Primary completion rate (% of total enrollments) in Colombia and Primary completion rate (% of total enrollments) in Switzerland?
Provide a short and direct response. 24.64. In the year 1983, what is the difference between the Primary completion rate (% of total enrollments) in Cyprus and Primary completion rate (% of total enrollments) in Guinea-Bissau?
Your answer should be compact. 71.23. In the year 1983, what is the difference between the Primary completion rate (% of total enrollments) of Cyprus and Primary completion rate (% of total enrollments) of Switzerland?
Provide a short and direct response. 25.75. In the year 1983, what is the difference between the Primary completion rate (% of total enrollments) of Guinea-Bissau and Primary completion rate (% of total enrollments) of Switzerland?
Your answer should be compact. -45.48. In the year 1984, what is the difference between the Primary completion rate (% of total enrollments) of Colombia and Primary completion rate (% of total enrollments) of Cyprus?
Your response must be concise. 0.77. In the year 1984, what is the difference between the Primary completion rate (% of total enrollments) of Colombia and Primary completion rate (% of total enrollments) of Guinea-Bissau?
Your response must be concise. 69.82. In the year 1984, what is the difference between the Primary completion rate (% of total enrollments) in Colombia and Primary completion rate (% of total enrollments) in Switzerland?
Offer a very short reply. 24.87. In the year 1984, what is the difference between the Primary completion rate (% of total enrollments) in Cyprus and Primary completion rate (% of total enrollments) in Guinea-Bissau?
Offer a terse response. 69.05. In the year 1984, what is the difference between the Primary completion rate (% of total enrollments) of Cyprus and Primary completion rate (% of total enrollments) of Switzerland?
Ensure brevity in your answer.  24.1. In the year 1984, what is the difference between the Primary completion rate (% of total enrollments) of Guinea-Bissau and Primary completion rate (% of total enrollments) of Switzerland?
Give a very brief answer. -44.95. In the year 1987, what is the difference between the Primary completion rate (% of total enrollments) in Colombia and Primary completion rate (% of total enrollments) in Cyprus?
Your answer should be very brief. 4.55. In the year 1987, what is the difference between the Primary completion rate (% of total enrollments) in Colombia and Primary completion rate (% of total enrollments) in Guinea-Bissau?
Make the answer very short. 68.59. In the year 1987, what is the difference between the Primary completion rate (% of total enrollments) in Colombia and Primary completion rate (% of total enrollments) in Switzerland?
Your answer should be very brief. 23.22. In the year 1987, what is the difference between the Primary completion rate (% of total enrollments) of Cyprus and Primary completion rate (% of total enrollments) of Guinea-Bissau?
Provide a short and direct response. 64.04. In the year 1987, what is the difference between the Primary completion rate (% of total enrollments) in Cyprus and Primary completion rate (% of total enrollments) in Switzerland?
Provide a short and direct response. 18.67. In the year 1987, what is the difference between the Primary completion rate (% of total enrollments) of Guinea-Bissau and Primary completion rate (% of total enrollments) of Switzerland?
Give a very brief answer. -45.37. In the year 1988, what is the difference between the Primary completion rate (% of total enrollments) of Colombia and Primary completion rate (% of total enrollments) of Cyprus?
Your answer should be very brief. -5.01. In the year 1988, what is the difference between the Primary completion rate (% of total enrollments) of Colombia and Primary completion rate (% of total enrollments) of Guinea-Bissau?
Give a very brief answer. 69.01. In the year 1988, what is the difference between the Primary completion rate (% of total enrollments) in Colombia and Primary completion rate (% of total enrollments) in Switzerland?
Your response must be concise. 23.53. In the year 1988, what is the difference between the Primary completion rate (% of total enrollments) in Cyprus and Primary completion rate (% of total enrollments) in Guinea-Bissau?
Your answer should be compact. 74.02. In the year 1988, what is the difference between the Primary completion rate (% of total enrollments) of Cyprus and Primary completion rate (% of total enrollments) of Switzerland?
Provide a succinct answer. 28.54. In the year 1988, what is the difference between the Primary completion rate (% of total enrollments) of Guinea-Bissau and Primary completion rate (% of total enrollments) of Switzerland?
Your answer should be very brief. -45.48. In the year 2000, what is the difference between the Primary completion rate (% of total enrollments) of Colombia and Primary completion rate (% of total enrollments) of Cyprus?
Ensure brevity in your answer.  0.04. In the year 2000, what is the difference between the Primary completion rate (% of total enrollments) in Colombia and Primary completion rate (% of total enrollments) in Guinea-Bissau?
Your response must be concise. 76.73. In the year 2000, what is the difference between the Primary completion rate (% of total enrollments) in Colombia and Primary completion rate (% of total enrollments) in Switzerland?
Your answer should be compact. -0.84. In the year 2000, what is the difference between the Primary completion rate (% of total enrollments) in Cyprus and Primary completion rate (% of total enrollments) in Guinea-Bissau?
Offer a terse response. 76.69. In the year 2000, what is the difference between the Primary completion rate (% of total enrollments) of Cyprus and Primary completion rate (% of total enrollments) of Switzerland?
Your answer should be compact. -0.88. In the year 2000, what is the difference between the Primary completion rate (% of total enrollments) in Guinea-Bissau and Primary completion rate (% of total enrollments) in Switzerland?
Provide a succinct answer. -77.57. In the year 2010, what is the difference between the Primary completion rate (% of total enrollments) in Colombia and Primary completion rate (% of total enrollments) in Cyprus?
Offer a terse response. 13.87. In the year 2010, what is the difference between the Primary completion rate (% of total enrollments) of Colombia and Primary completion rate (% of total enrollments) of Guinea-Bissau?
Ensure brevity in your answer.  58.04. In the year 2010, what is the difference between the Primary completion rate (% of total enrollments) in Colombia and Primary completion rate (% of total enrollments) in Switzerland?
Your answer should be compact. 17.19. In the year 2010, what is the difference between the Primary completion rate (% of total enrollments) of Cyprus and Primary completion rate (% of total enrollments) of Guinea-Bissau?
Ensure brevity in your answer.  44.17. In the year 2010, what is the difference between the Primary completion rate (% of total enrollments) of Cyprus and Primary completion rate (% of total enrollments) of Switzerland?
Offer a terse response. 3.32. In the year 2010, what is the difference between the Primary completion rate (% of total enrollments) of Guinea-Bissau and Primary completion rate (% of total enrollments) of Switzerland?
Ensure brevity in your answer.  -40.85. What is the ratio of the Primary completion rate (% of total enrollments) in Colombia in 1982 to that in 1983?
Give a very brief answer. 0.96. What is the ratio of the Primary completion rate (% of total enrollments) of Cyprus in 1982 to that in 1983?
Ensure brevity in your answer.  1.01. What is the ratio of the Primary completion rate (% of total enrollments) in Guinea-Bissau in 1982 to that in 1983?
Your answer should be very brief. 1.35. What is the ratio of the Primary completion rate (% of total enrollments) in Switzerland in 1982 to that in 1983?
Provide a short and direct response. 0.99. What is the ratio of the Primary completion rate (% of total enrollments) in Colombia in 1982 to that in 1984?
Make the answer very short. 0.96. What is the ratio of the Primary completion rate (% of total enrollments) of Cyprus in 1982 to that in 1984?
Offer a very short reply. 1.04. What is the ratio of the Primary completion rate (% of total enrollments) of Guinea-Bissau in 1982 to that in 1984?
Give a very brief answer. 1.35. What is the ratio of the Primary completion rate (% of total enrollments) in Switzerland in 1982 to that in 1984?
Provide a short and direct response. 1. What is the ratio of the Primary completion rate (% of total enrollments) of Colombia in 1982 to that in 1987?
Provide a short and direct response. 1.01. What is the ratio of the Primary completion rate (% of total enrollments) in Cyprus in 1982 to that in 1987?
Make the answer very short. 1.15. What is the ratio of the Primary completion rate (% of total enrollments) of Guinea-Bissau in 1982 to that in 1987?
Provide a succinct answer. 2.06. What is the ratio of the Primary completion rate (% of total enrollments) of Switzerland in 1982 to that in 1987?
Your answer should be very brief. 1.04. What is the ratio of the Primary completion rate (% of total enrollments) in Colombia in 1982 to that in 1988?
Provide a short and direct response. 1.02. What is the ratio of the Primary completion rate (% of total enrollments) in Guinea-Bissau in 1982 to that in 1988?
Provide a succinct answer. 2.73. What is the ratio of the Primary completion rate (% of total enrollments) of Switzerland in 1982 to that in 1988?
Provide a succinct answer. 1.06. What is the ratio of the Primary completion rate (% of total enrollments) in Colombia in 1982 to that in 2000?
Your answer should be very brief. 0.76. What is the ratio of the Primary completion rate (% of total enrollments) of Cyprus in 1982 to that in 2000?
Make the answer very short. 0.81. What is the ratio of the Primary completion rate (% of total enrollments) of Guinea-Bissau in 1982 to that in 2000?
Your answer should be very brief. 0.47. What is the ratio of the Primary completion rate (% of total enrollments) of Switzerland in 1982 to that in 2000?
Provide a succinct answer. 0.53. What is the ratio of the Primary completion rate (% of total enrollments) of Colombia in 1982 to that in 2010?
Your response must be concise. 0.65. What is the ratio of the Primary completion rate (% of total enrollments) in Cyprus in 1982 to that in 2010?
Make the answer very short. 0.78. What is the ratio of the Primary completion rate (% of total enrollments) in Guinea-Bissau in 1982 to that in 2010?
Offer a terse response. 0.17. What is the ratio of the Primary completion rate (% of total enrollments) of Switzerland in 1982 to that in 2010?
Offer a terse response. 0.54. What is the ratio of the Primary completion rate (% of total enrollments) of Colombia in 1983 to that in 1984?
Provide a succinct answer. 1. What is the ratio of the Primary completion rate (% of total enrollments) of Cyprus in 1983 to that in 1984?
Your answer should be very brief. 1.03. What is the ratio of the Primary completion rate (% of total enrollments) in Guinea-Bissau in 1983 to that in 1984?
Your answer should be very brief. 1. What is the ratio of the Primary completion rate (% of total enrollments) in Switzerland in 1983 to that in 1984?
Give a very brief answer. 1.01. What is the ratio of the Primary completion rate (% of total enrollments) of Colombia in 1983 to that in 1987?
Make the answer very short. 1.05. What is the ratio of the Primary completion rate (% of total enrollments) of Cyprus in 1983 to that in 1987?
Your response must be concise. 1.14. What is the ratio of the Primary completion rate (% of total enrollments) in Guinea-Bissau in 1983 to that in 1987?
Make the answer very short. 1.52. What is the ratio of the Primary completion rate (% of total enrollments) in Switzerland in 1983 to that in 1987?
Keep it short and to the point. 1.05. What is the ratio of the Primary completion rate (% of total enrollments) in Colombia in 1983 to that in 1988?
Offer a terse response. 1.07. What is the ratio of the Primary completion rate (% of total enrollments) in Cyprus in 1983 to that in 1988?
Offer a very short reply. 1.01. What is the ratio of the Primary completion rate (% of total enrollments) in Guinea-Bissau in 1983 to that in 1988?
Ensure brevity in your answer.  2.01. What is the ratio of the Primary completion rate (% of total enrollments) in Switzerland in 1983 to that in 1988?
Offer a terse response. 1.07. What is the ratio of the Primary completion rate (% of total enrollments) in Colombia in 1983 to that in 2000?
Provide a succinct answer. 0.79. What is the ratio of the Primary completion rate (% of total enrollments) of Cyprus in 1983 to that in 2000?
Provide a succinct answer. 0.81. What is the ratio of the Primary completion rate (% of total enrollments) in Guinea-Bissau in 1983 to that in 2000?
Give a very brief answer. 0.35. What is the ratio of the Primary completion rate (% of total enrollments) of Switzerland in 1983 to that in 2000?
Provide a short and direct response. 0.54. What is the ratio of the Primary completion rate (% of total enrollments) of Colombia in 1983 to that in 2010?
Your answer should be compact. 0.67. What is the ratio of the Primary completion rate (% of total enrollments) in Cyprus in 1983 to that in 2010?
Your answer should be very brief. 0.78. What is the ratio of the Primary completion rate (% of total enrollments) of Guinea-Bissau in 1983 to that in 2010?
Provide a short and direct response. 0.13. What is the ratio of the Primary completion rate (% of total enrollments) of Switzerland in 1983 to that in 2010?
Give a very brief answer. 0.54. What is the ratio of the Primary completion rate (% of total enrollments) in Colombia in 1984 to that in 1987?
Provide a succinct answer. 1.05. What is the ratio of the Primary completion rate (% of total enrollments) in Cyprus in 1984 to that in 1987?
Your response must be concise. 1.11. What is the ratio of the Primary completion rate (% of total enrollments) in Guinea-Bissau in 1984 to that in 1987?
Offer a terse response. 1.53. What is the ratio of the Primary completion rate (% of total enrollments) in Switzerland in 1984 to that in 1987?
Your answer should be very brief. 1.04. What is the ratio of the Primary completion rate (% of total enrollments) of Colombia in 1984 to that in 1988?
Your answer should be compact. 1.06. What is the ratio of the Primary completion rate (% of total enrollments) of Cyprus in 1984 to that in 1988?
Your answer should be compact. 0.98. What is the ratio of the Primary completion rate (% of total enrollments) in Guinea-Bissau in 1984 to that in 1988?
Make the answer very short. 2.02. What is the ratio of the Primary completion rate (% of total enrollments) in Switzerland in 1984 to that in 1988?
Your response must be concise. 1.06. What is the ratio of the Primary completion rate (% of total enrollments) of Colombia in 1984 to that in 2000?
Offer a very short reply. 0.79. What is the ratio of the Primary completion rate (% of total enrollments) of Cyprus in 1984 to that in 2000?
Your answer should be compact. 0.78. What is the ratio of the Primary completion rate (% of total enrollments) of Guinea-Bissau in 1984 to that in 2000?
Your response must be concise. 0.35. What is the ratio of the Primary completion rate (% of total enrollments) of Switzerland in 1984 to that in 2000?
Your response must be concise. 0.53. What is the ratio of the Primary completion rate (% of total enrollments) of Colombia in 1984 to that in 2010?
Your answer should be compact. 0.67. What is the ratio of the Primary completion rate (% of total enrollments) of Cyprus in 1984 to that in 2010?
Provide a succinct answer. 0.76. What is the ratio of the Primary completion rate (% of total enrollments) of Guinea-Bissau in 1984 to that in 2010?
Give a very brief answer. 0.13. What is the ratio of the Primary completion rate (% of total enrollments) of Switzerland in 1984 to that in 2010?
Make the answer very short. 0.53. What is the ratio of the Primary completion rate (% of total enrollments) in Colombia in 1987 to that in 1988?
Provide a short and direct response. 1.01. What is the ratio of the Primary completion rate (% of total enrollments) of Cyprus in 1987 to that in 1988?
Your answer should be very brief. 0.89. What is the ratio of the Primary completion rate (% of total enrollments) in Guinea-Bissau in 1987 to that in 1988?
Your answer should be very brief. 1.32. What is the ratio of the Primary completion rate (% of total enrollments) of Switzerland in 1987 to that in 1988?
Your answer should be compact. 1.02. What is the ratio of the Primary completion rate (% of total enrollments) of Colombia in 1987 to that in 2000?
Provide a succinct answer. 0.75. What is the ratio of the Primary completion rate (% of total enrollments) in Cyprus in 1987 to that in 2000?
Your answer should be compact. 0.71. What is the ratio of the Primary completion rate (% of total enrollments) of Guinea-Bissau in 1987 to that in 2000?
Make the answer very short. 0.23. What is the ratio of the Primary completion rate (% of total enrollments) in Switzerland in 1987 to that in 2000?
Give a very brief answer. 0.51. What is the ratio of the Primary completion rate (% of total enrollments) in Colombia in 1987 to that in 2010?
Give a very brief answer. 0.64. What is the ratio of the Primary completion rate (% of total enrollments) in Cyprus in 1987 to that in 2010?
Provide a short and direct response. 0.68. What is the ratio of the Primary completion rate (% of total enrollments) of Guinea-Bissau in 1987 to that in 2010?
Make the answer very short. 0.08. What is the ratio of the Primary completion rate (% of total enrollments) of Switzerland in 1987 to that in 2010?
Your answer should be compact. 0.51. What is the ratio of the Primary completion rate (% of total enrollments) in Colombia in 1988 to that in 2000?
Offer a very short reply. 0.75. What is the ratio of the Primary completion rate (% of total enrollments) of Cyprus in 1988 to that in 2000?
Provide a short and direct response. 0.8. What is the ratio of the Primary completion rate (% of total enrollments) in Guinea-Bissau in 1988 to that in 2000?
Give a very brief answer. 0.17. What is the ratio of the Primary completion rate (% of total enrollments) in Switzerland in 1988 to that in 2000?
Give a very brief answer. 0.5. What is the ratio of the Primary completion rate (% of total enrollments) in Colombia in 1988 to that in 2010?
Provide a succinct answer. 0.63. What is the ratio of the Primary completion rate (% of total enrollments) in Cyprus in 1988 to that in 2010?
Make the answer very short. 0.77. What is the ratio of the Primary completion rate (% of total enrollments) in Guinea-Bissau in 1988 to that in 2010?
Offer a terse response. 0.06. What is the ratio of the Primary completion rate (% of total enrollments) of Switzerland in 1988 to that in 2010?
Make the answer very short. 0.5. What is the ratio of the Primary completion rate (% of total enrollments) in Colombia in 2000 to that in 2010?
Make the answer very short. 0.85. What is the ratio of the Primary completion rate (% of total enrollments) of Cyprus in 2000 to that in 2010?
Your response must be concise. 0.96. What is the ratio of the Primary completion rate (% of total enrollments) of Guinea-Bissau in 2000 to that in 2010?
Provide a succinct answer. 0.36. What is the ratio of the Primary completion rate (% of total enrollments) in Switzerland in 2000 to that in 2010?
Give a very brief answer. 1.01. What is the difference between the highest and the second highest Primary completion rate (% of total enrollments) of Colombia?
Offer a terse response. 17.41. What is the difference between the highest and the second highest Primary completion rate (% of total enrollments) of Cyprus?
Make the answer very short. 3.59. What is the difference between the highest and the second highest Primary completion rate (% of total enrollments) of Guinea-Bissau?
Keep it short and to the point. 36.1. What is the difference between the highest and the second highest Primary completion rate (% of total enrollments) in Switzerland?
Offer a terse response. 0.61. What is the difference between the highest and the lowest Primary completion rate (% of total enrollments) in Colombia?
Give a very brief answer. 42.14. What is the difference between the highest and the lowest Primary completion rate (% of total enrollments) of Cyprus?
Make the answer very short. 32.09. What is the difference between the highest and the lowest Primary completion rate (% of total enrollments) of Guinea-Bissau?
Provide a short and direct response. 53.11. What is the difference between the highest and the lowest Primary completion rate (% of total enrollments) of Switzerland?
Offer a terse response. 49.09. 